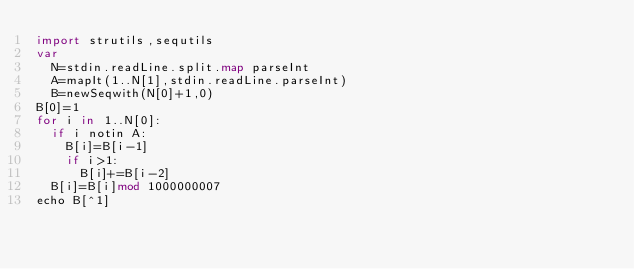<code> <loc_0><loc_0><loc_500><loc_500><_Nim_>import strutils,sequtils
var
  N=stdin.readLine.split.map parseInt
  A=mapIt(1..N[1],stdin.readLine.parseInt)
  B=newSeqwith(N[0]+1,0)
B[0]=1
for i in 1..N[0]:
  if i notin A:
    B[i]=B[i-1]
    if i>1:
      B[i]+=B[i-2]
  B[i]=B[i]mod 1000000007
echo B[^1]</code> 